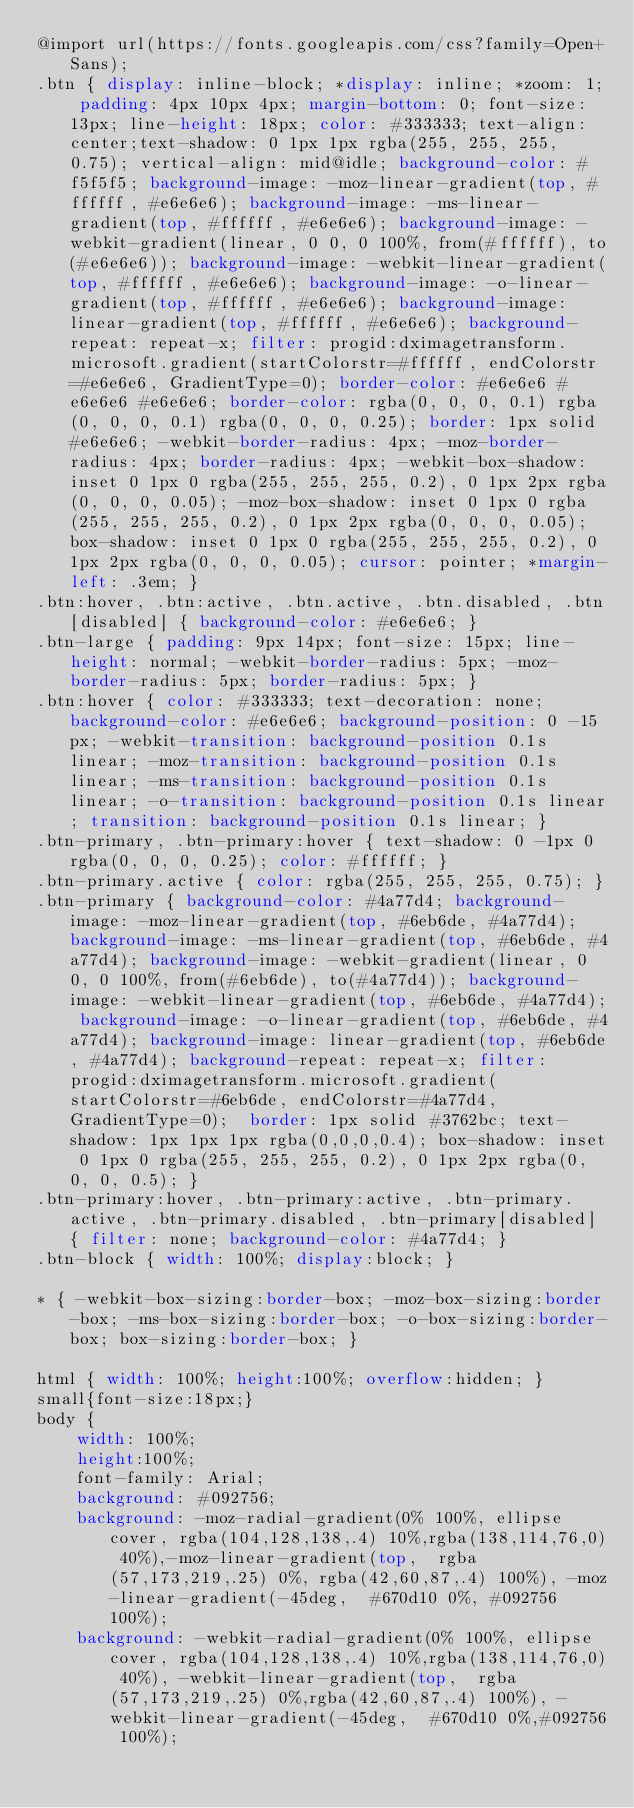<code> <loc_0><loc_0><loc_500><loc_500><_CSS_>@import url(https://fonts.googleapis.com/css?family=Open+Sans);
.btn { display: inline-block; *display: inline; *zoom: 1; padding: 4px 10px 4px; margin-bottom: 0; font-size: 13px; line-height: 18px; color: #333333; text-align: center;text-shadow: 0 1px 1px rgba(255, 255, 255, 0.75); vertical-align: mid@idle; background-color: #f5f5f5; background-image: -moz-linear-gradient(top, #ffffff, #e6e6e6); background-image: -ms-linear-gradient(top, #ffffff, #e6e6e6); background-image: -webkit-gradient(linear, 0 0, 0 100%, from(#ffffff), to(#e6e6e6)); background-image: -webkit-linear-gradient(top, #ffffff, #e6e6e6); background-image: -o-linear-gradient(top, #ffffff, #e6e6e6); background-image: linear-gradient(top, #ffffff, #e6e6e6); background-repeat: repeat-x; filter: progid:dximagetransform.microsoft.gradient(startColorstr=#ffffff, endColorstr=#e6e6e6, GradientType=0); border-color: #e6e6e6 #e6e6e6 #e6e6e6; border-color: rgba(0, 0, 0, 0.1) rgba(0, 0, 0, 0.1) rgba(0, 0, 0, 0.25); border: 1px solid #e6e6e6; -webkit-border-radius: 4px; -moz-border-radius: 4px; border-radius: 4px; -webkit-box-shadow: inset 0 1px 0 rgba(255, 255, 255, 0.2), 0 1px 2px rgba(0, 0, 0, 0.05); -moz-box-shadow: inset 0 1px 0 rgba(255, 255, 255, 0.2), 0 1px 2px rgba(0, 0, 0, 0.05); box-shadow: inset 0 1px 0 rgba(255, 255, 255, 0.2), 0 1px 2px rgba(0, 0, 0, 0.05); cursor: pointer; *margin-left: .3em; }
.btn:hover, .btn:active, .btn.active, .btn.disabled, .btn[disabled] { background-color: #e6e6e6; }
.btn-large { padding: 9px 14px; font-size: 15px; line-height: normal; -webkit-border-radius: 5px; -moz-border-radius: 5px; border-radius: 5px; }
.btn:hover { color: #333333; text-decoration: none; background-color: #e6e6e6; background-position: 0 -15px; -webkit-transition: background-position 0.1s linear; -moz-transition: background-position 0.1s linear; -ms-transition: background-position 0.1s linear; -o-transition: background-position 0.1s linear; transition: background-position 0.1s linear; }
.btn-primary, .btn-primary:hover { text-shadow: 0 -1px 0 rgba(0, 0, 0, 0.25); color: #ffffff; }
.btn-primary.active { color: rgba(255, 255, 255, 0.75); }
.btn-primary { background-color: #4a77d4; background-image: -moz-linear-gradient(top, #6eb6de, #4a77d4); background-image: -ms-linear-gradient(top, #6eb6de, #4a77d4); background-image: -webkit-gradient(linear, 0 0, 0 100%, from(#6eb6de), to(#4a77d4)); background-image: -webkit-linear-gradient(top, #6eb6de, #4a77d4); background-image: -o-linear-gradient(top, #6eb6de, #4a77d4); background-image: linear-gradient(top, #6eb6de, #4a77d4); background-repeat: repeat-x; filter: progid:dximagetransform.microsoft.gradient(startColorstr=#6eb6de, endColorstr=#4a77d4, GradientType=0);  border: 1px solid #3762bc; text-shadow: 1px 1px 1px rgba(0,0,0,0.4); box-shadow: inset 0 1px 0 rgba(255, 255, 255, 0.2), 0 1px 2px rgba(0, 0, 0, 0.5); }
.btn-primary:hover, .btn-primary:active, .btn-primary.active, .btn-primary.disabled, .btn-primary[disabled] { filter: none; background-color: #4a77d4; }
.btn-block { width: 100%; display:block; }

* { -webkit-box-sizing:border-box; -moz-box-sizing:border-box; -ms-box-sizing:border-box; -o-box-sizing:border-box; box-sizing:border-box; }

html { width: 100%; height:100%; overflow:hidden; }
small{font-size:18px;}
body { 
	width: 100%;
	height:100%;
	font-family: Arial;
	background: #092756;
	background: -moz-radial-gradient(0% 100%, ellipse cover, rgba(104,128,138,.4) 10%,rgba(138,114,76,0) 40%),-moz-linear-gradient(top,  rgba(57,173,219,.25) 0%, rgba(42,60,87,.4) 100%), -moz-linear-gradient(-45deg,  #670d10 0%, #092756 100%);
	background: -webkit-radial-gradient(0% 100%, ellipse cover, rgba(104,128,138,.4) 10%,rgba(138,114,76,0) 40%), -webkit-linear-gradient(top,  rgba(57,173,219,.25) 0%,rgba(42,60,87,.4) 100%), -webkit-linear-gradient(-45deg,  #670d10 0%,#092756 100%);</code> 